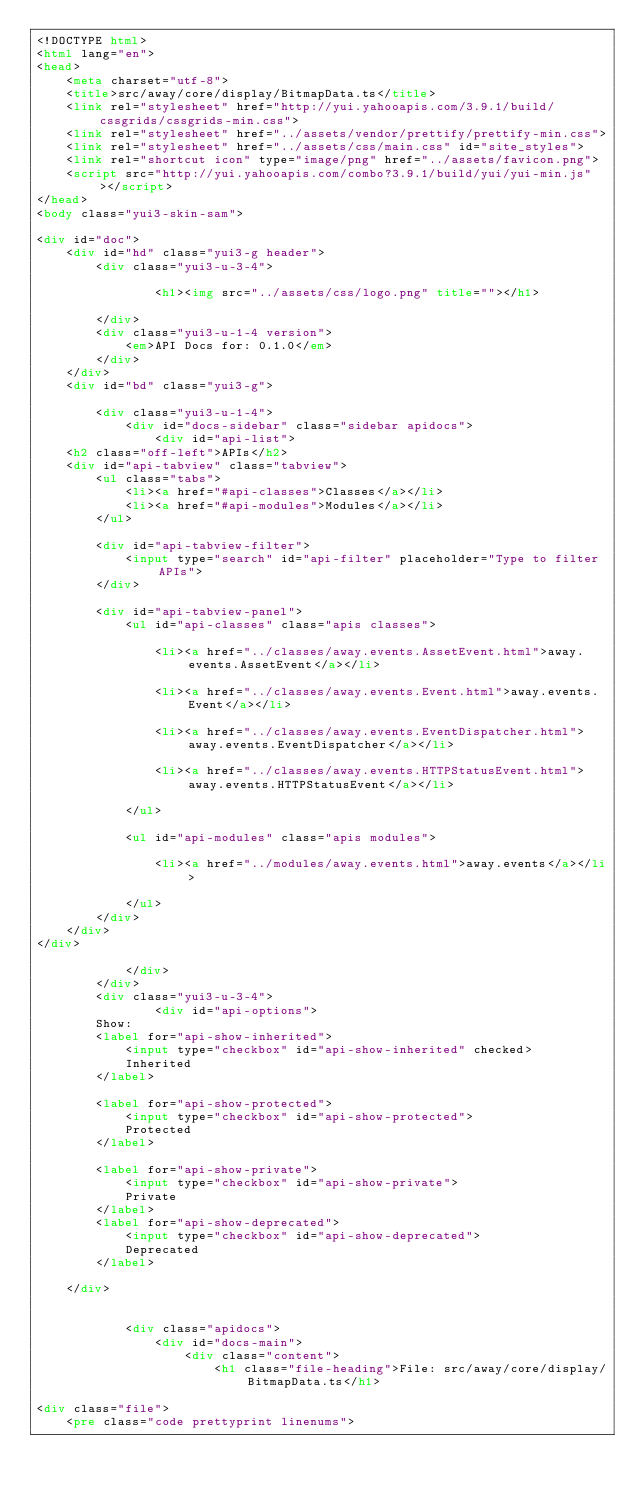<code> <loc_0><loc_0><loc_500><loc_500><_HTML_><!DOCTYPE html>
<html lang="en">
<head>
    <meta charset="utf-8">
    <title>src/away/core/display/BitmapData.ts</title>
    <link rel="stylesheet" href="http://yui.yahooapis.com/3.9.1/build/cssgrids/cssgrids-min.css">
    <link rel="stylesheet" href="../assets/vendor/prettify/prettify-min.css">
    <link rel="stylesheet" href="../assets/css/main.css" id="site_styles">
    <link rel="shortcut icon" type="image/png" href="../assets/favicon.png">
    <script src="http://yui.yahooapis.com/combo?3.9.1/build/yui/yui-min.js"></script>
</head>
<body class="yui3-skin-sam">

<div id="doc">
    <div id="hd" class="yui3-g header">
        <div class="yui3-u-3-4">
            
                <h1><img src="../assets/css/logo.png" title=""></h1>
            
        </div>
        <div class="yui3-u-1-4 version">
            <em>API Docs for: 0.1.0</em>
        </div>
    </div>
    <div id="bd" class="yui3-g">

        <div class="yui3-u-1-4">
            <div id="docs-sidebar" class="sidebar apidocs">
                <div id="api-list">
    <h2 class="off-left">APIs</h2>
    <div id="api-tabview" class="tabview">
        <ul class="tabs">
            <li><a href="#api-classes">Classes</a></li>
            <li><a href="#api-modules">Modules</a></li>
        </ul>

        <div id="api-tabview-filter">
            <input type="search" id="api-filter" placeholder="Type to filter APIs">
        </div>

        <div id="api-tabview-panel">
            <ul id="api-classes" class="apis classes">
            
                <li><a href="../classes/away.events.AssetEvent.html">away.events.AssetEvent</a></li>
            
                <li><a href="../classes/away.events.Event.html">away.events.Event</a></li>
            
                <li><a href="../classes/away.events.EventDispatcher.html">away.events.EventDispatcher</a></li>
            
                <li><a href="../classes/away.events.HTTPStatusEvent.html">away.events.HTTPStatusEvent</a></li>
            
            </ul>

            <ul id="api-modules" class="apis modules">
            
                <li><a href="../modules/away.events.html">away.events</a></li>
            
            </ul>
        </div>
    </div>
</div>

            </div>
        </div>
        <div class="yui3-u-3-4">
                <div id="api-options">
        Show:
        <label for="api-show-inherited">
            <input type="checkbox" id="api-show-inherited" checked>
            Inherited
        </label>

        <label for="api-show-protected">
            <input type="checkbox" id="api-show-protected">
            Protected
        </label>

        <label for="api-show-private">
            <input type="checkbox" id="api-show-private">
            Private
        </label>
        <label for="api-show-deprecated">
            <input type="checkbox" id="api-show-deprecated">
            Deprecated
        </label>

    </div>


            <div class="apidocs">
                <div id="docs-main">
                    <div class="content">
                        <h1 class="file-heading">File: src/away/core/display/BitmapData.ts</h1>

<div class="file">
    <pre class="code prettyprint linenums"></code> 